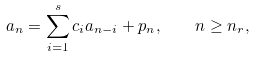<formula> <loc_0><loc_0><loc_500><loc_500>a _ { n } = \sum _ { i = 1 } ^ { s } c _ { i } a _ { n - i } + p _ { n } , \quad n \geq n _ { r } ,</formula> 